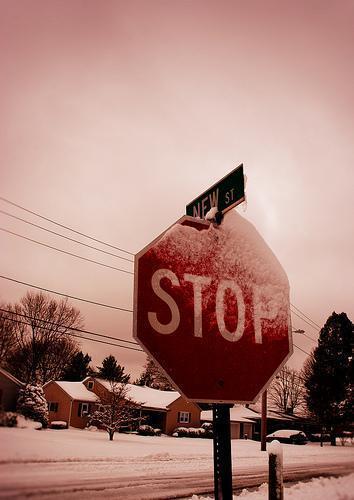How many vehicles or pictured?
Give a very brief answer. 1. How many powerlines are there?
Give a very brief answer. 6. 